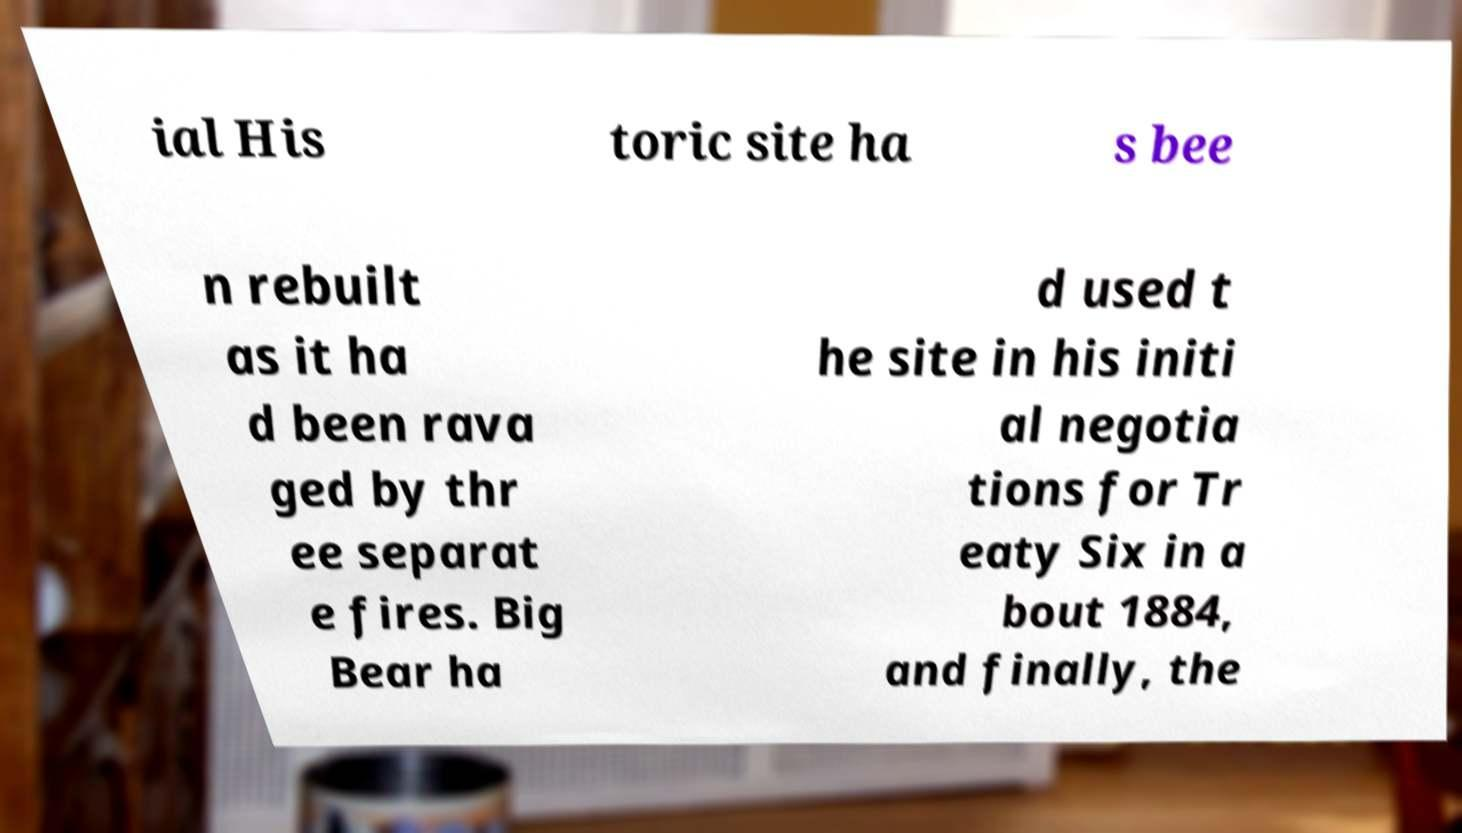Please read and relay the text visible in this image. What does it say? ial His toric site ha s bee n rebuilt as it ha d been rava ged by thr ee separat e fires. Big Bear ha d used t he site in his initi al negotia tions for Tr eaty Six in a bout 1884, and finally, the 